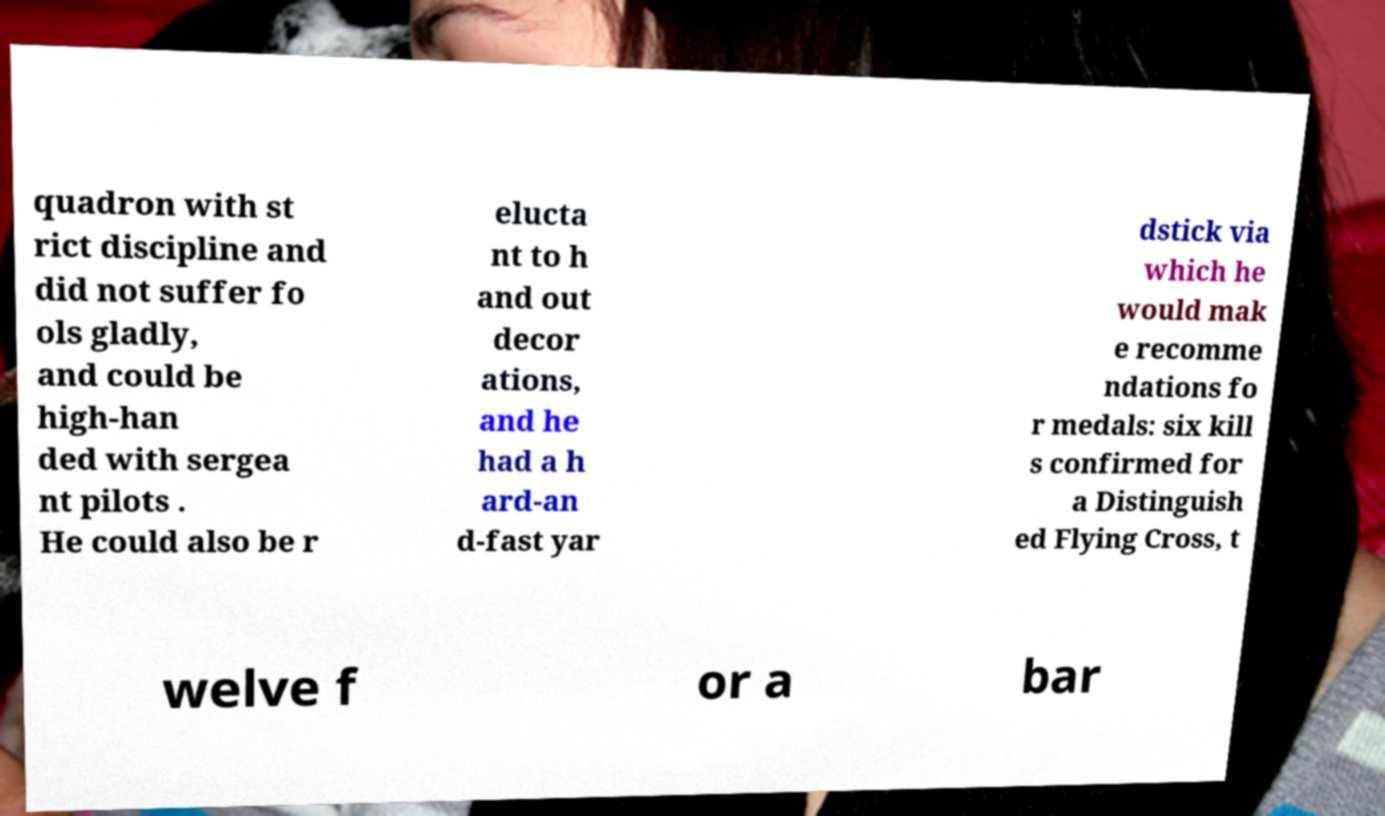Could you assist in decoding the text presented in this image and type it out clearly? quadron with st rict discipline and did not suffer fo ols gladly, and could be high-han ded with sergea nt pilots . He could also be r elucta nt to h and out decor ations, and he had a h ard-an d-fast yar dstick via which he would mak e recomme ndations fo r medals: six kill s confirmed for a Distinguish ed Flying Cross, t welve f or a bar 